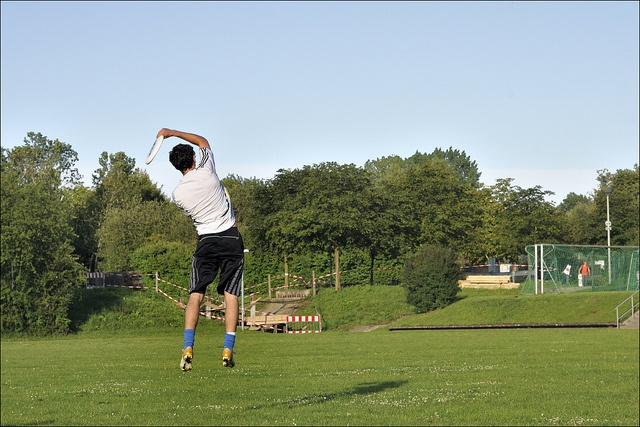Describe the objects in this image and their specific colors. I can see people in black, lightgray, gray, and tan tones, frisbee in black, lightgray, and darkgray tones, people in black, gray, salmon, and tan tones, and people in black, teal, white, and olive tones in this image. 